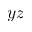Convert formula to latex. <formula><loc_0><loc_0><loc_500><loc_500>y z</formula> 